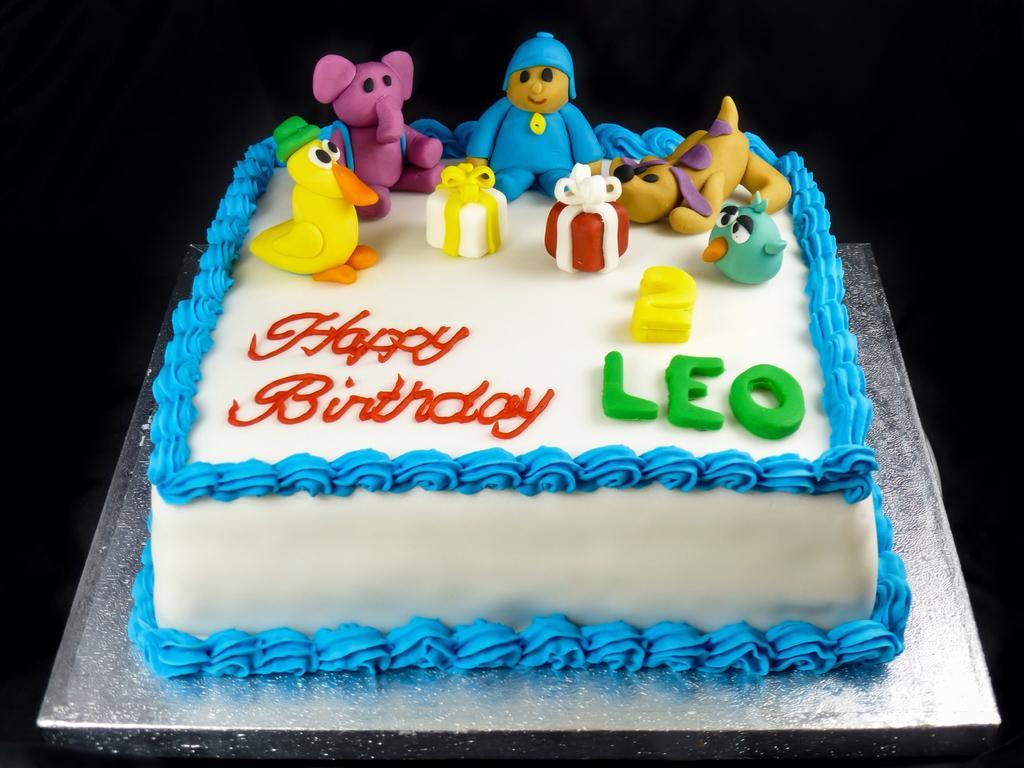Please provide a concise description of this image. In this image I see a cake which is of white, blue, yellow, green, red, purple and light brown in color and I see something is written over here and it is dark in the background. 